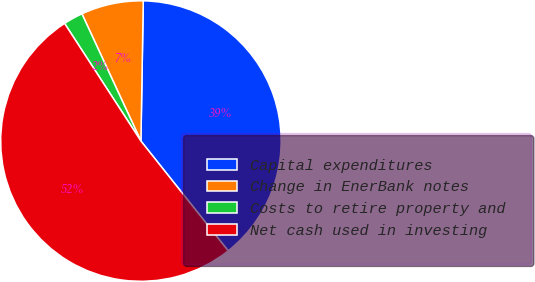Convert chart. <chart><loc_0><loc_0><loc_500><loc_500><pie_chart><fcel>Capital expenditures<fcel>Change in EnerBank notes<fcel>Costs to retire property and<fcel>Net cash used in investing<nl><fcel>39.05%<fcel>7.18%<fcel>2.25%<fcel>51.53%<nl></chart> 